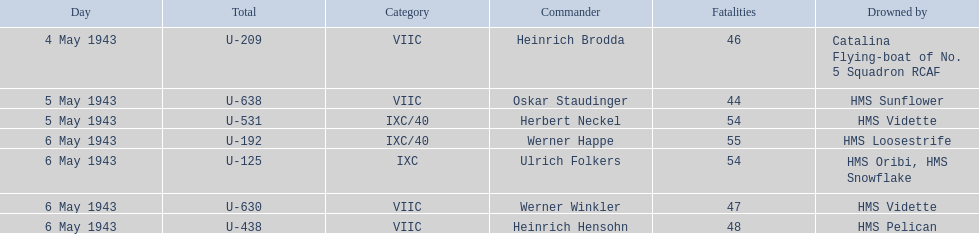How many additional casualties took place on may 6 in comparison to may 4? 158. Would you be able to parse every entry in this table? {'header': ['Day', 'Total', 'Category', 'Commander', 'Fatalities', 'Drowned by'], 'rows': [['4 May 1943', 'U-209', 'VIIC', 'Heinrich Brodda', '46', 'Catalina Flying-boat of No. 5 Squadron RCAF'], ['5 May 1943', 'U-638', 'VIIC', 'Oskar Staudinger', '44', 'HMS Sunflower'], ['5 May 1943', 'U-531', 'IXC/40', 'Herbert Neckel', '54', 'HMS Vidette'], ['6 May 1943', 'U-192', 'IXC/40', 'Werner Happe', '55', 'HMS Loosestrife'], ['6 May 1943', 'U-125', 'IXC', 'Ulrich Folkers', '54', 'HMS Oribi, HMS Snowflake'], ['6 May 1943', 'U-630', 'VIIC', 'Werner Winkler', '47', 'HMS Vidette'], ['6 May 1943', 'U-438', 'VIIC', 'Heinrich Hensohn', '48', 'HMS Pelican']]} 